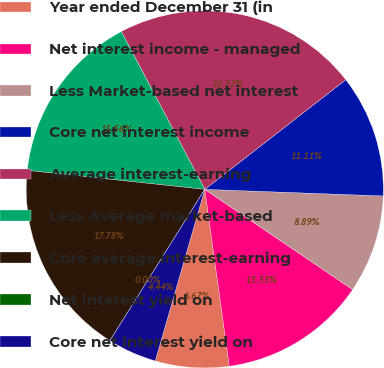<chart> <loc_0><loc_0><loc_500><loc_500><pie_chart><fcel>Year ended December 31 (in<fcel>Net interest income - managed<fcel>Less Market-based net interest<fcel>Core net interest income<fcel>Average interest-earning<fcel>Less Average market-based<fcel>Core average interest-earning<fcel>Net interest yield on<fcel>Core net interest yield on<nl><fcel>6.67%<fcel>13.33%<fcel>8.89%<fcel>11.11%<fcel>22.22%<fcel>15.56%<fcel>17.78%<fcel>0.0%<fcel>4.44%<nl></chart> 